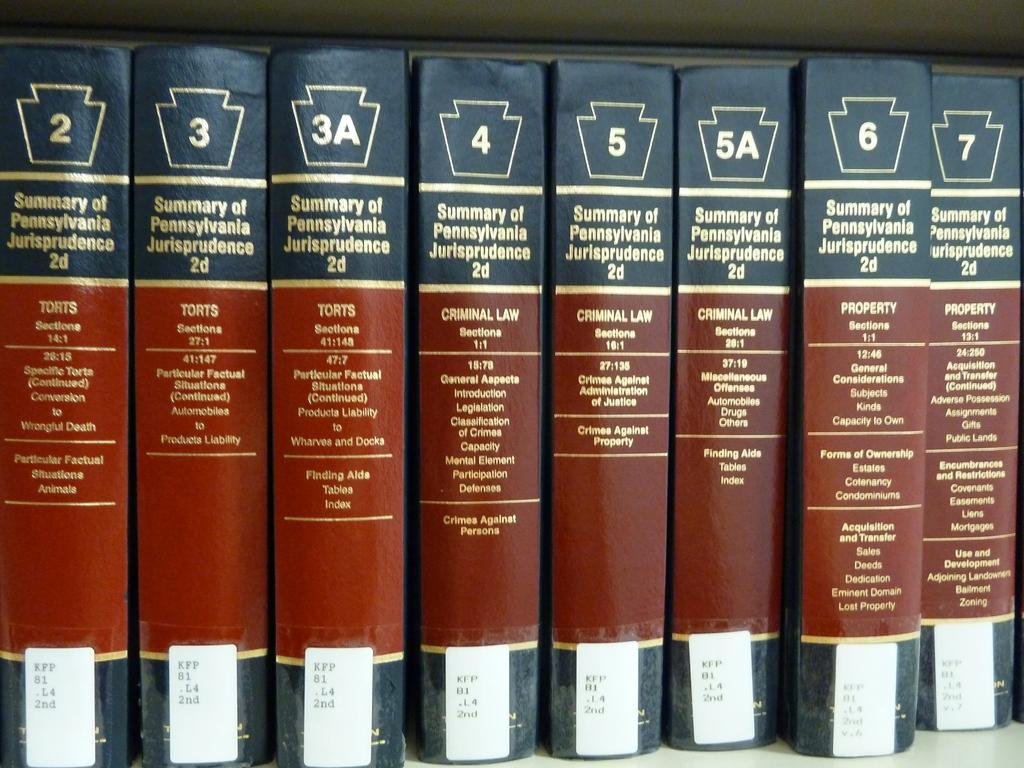<image>
Describe the image concisely. Several volumes of books about Pennsylvania law are lined up on a library shelf. 